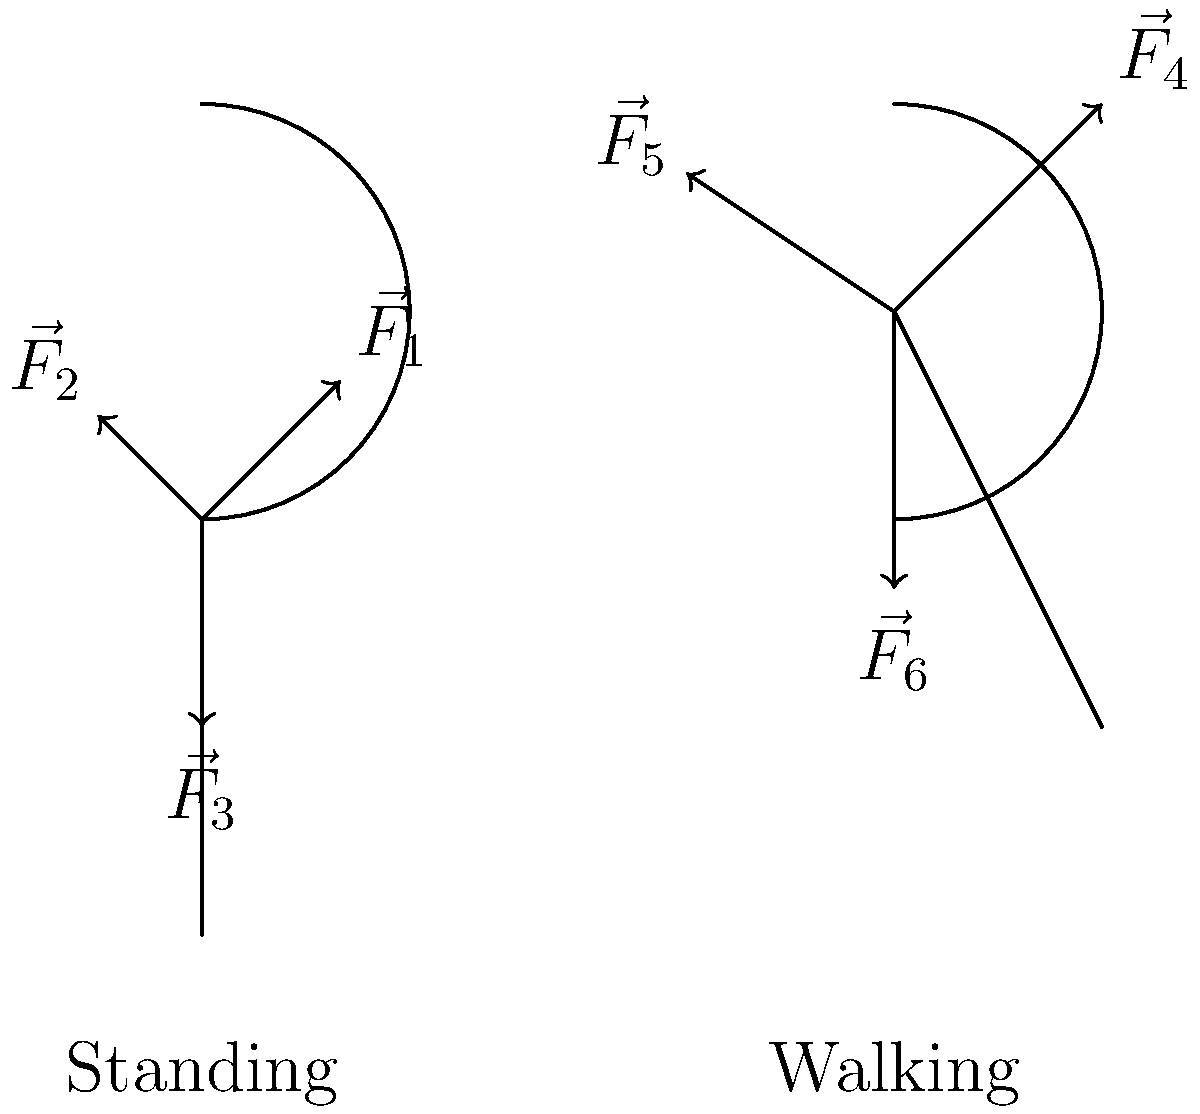Analyze the vector diagrams representing joint reaction forces in the hip during standing and walking. Which activity likely produces a greater resultant force on the hip joint, and how might this relate to the ethical considerations of recommending high-impact activities for individuals with hip conditions? To answer this question, we need to consider the following steps:

1. Analyze the vector diagrams:
   a. Standing (left diagram):
      - $\vec{F}_1$: Upward and lateral force (abductor muscles)
      - $\vec{F}_2$: Medial force (joint reaction)
      - $\vec{F}_3$: Downward force (body weight)
   b. Walking (right diagram):
      - $\vec{F}_4$: Upward and lateral force (abductor muscles, larger magnitude)
      - $\vec{F}_5$: Medial force (joint reaction, larger magnitude)
      - $\vec{F}_6$: Downward force (body weight + impact force)

2. Compare the magnitudes of the vectors:
   - The vectors in the walking diagram appear larger than those in the standing diagram.
   - The angle between $\vec{F}_4$ and $\vec{F}_5$ is greater than between $\vec{F}_1$ and $\vec{F}_2$.

3. Calculate the resultant force:
   - The resultant force is the vector sum of all forces acting on the joint.
   - In both cases, the resultant force would be approximately vertical.
   - The larger magnitudes in the walking diagram suggest a greater resultant force.

4. Consider the ethical implications:
   - Greater forces on the hip joint during walking may increase the risk of injury or pain for individuals with hip conditions.
   - From a deontological perspective, we must consider the duty to protect patients from harm.
   - However, we also have a duty to promote overall health and well-being, which may involve some level of physical activity.

5. Ethical considerations for recommending high-impact activities:
   - The principle of beneficence (doing good) must be balanced against non-maleficence (avoiding harm).
   - Informed consent becomes crucial: patients must understand the risks and benefits.
   - Individual assessment is necessary to determine appropriate activity levels.
   - Alternative low-impact activities might be preferable for those with hip conditions.
Answer: Walking produces greater resultant force; ethically complex due to potential benefits vs. risks of high-impact activities for hip conditions. 